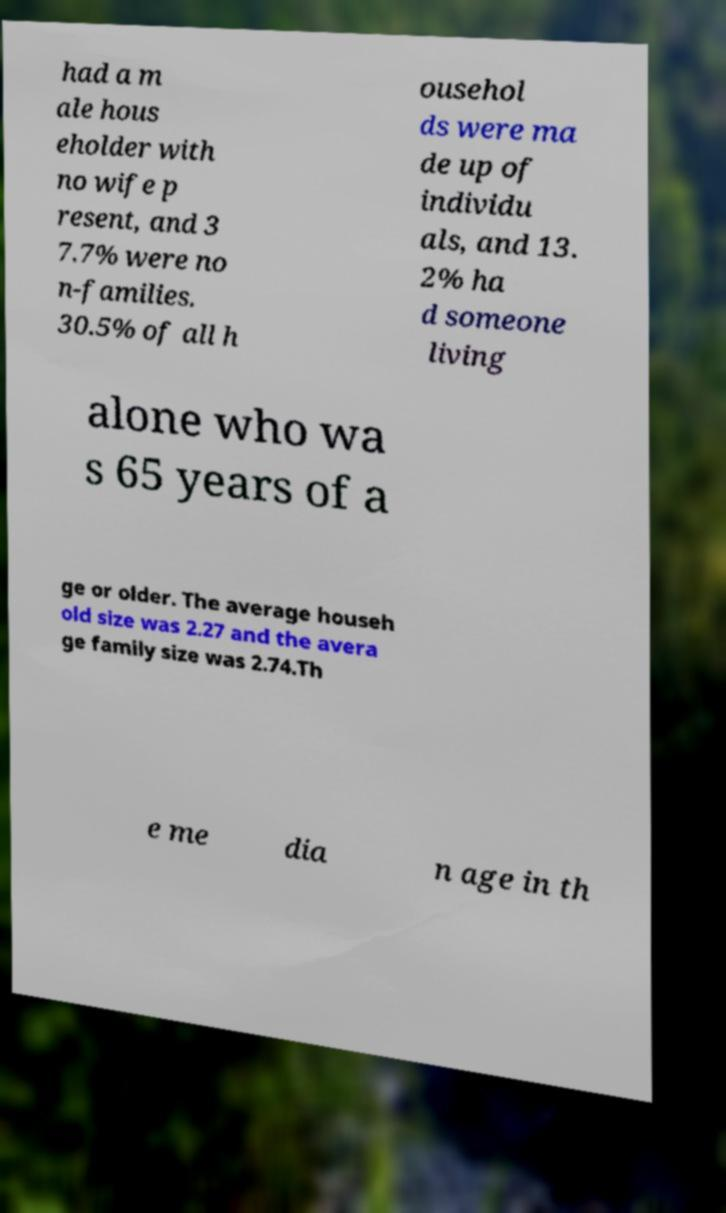I need the written content from this picture converted into text. Can you do that? had a m ale hous eholder with no wife p resent, and 3 7.7% were no n-families. 30.5% of all h ousehol ds were ma de up of individu als, and 13. 2% ha d someone living alone who wa s 65 years of a ge or older. The average househ old size was 2.27 and the avera ge family size was 2.74.Th e me dia n age in th 